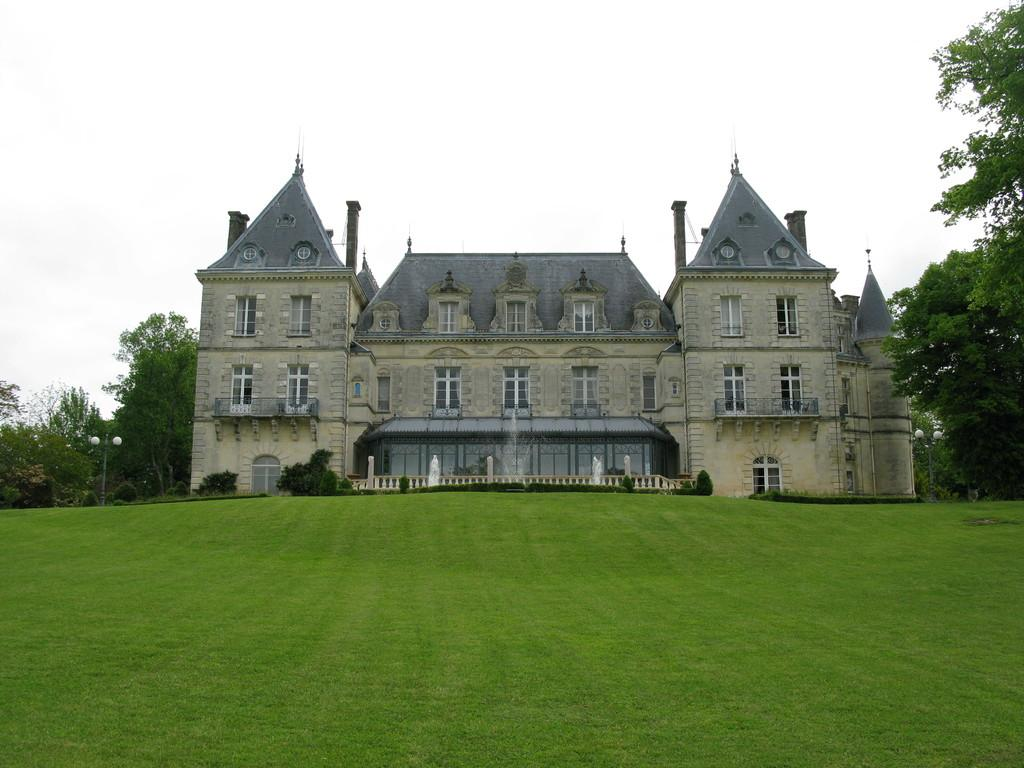What is the main structure in the center of the image? There is a building in the center of the image. What type of natural elements can be seen in the image? There are trees in the image. What are the vertical structures in the image? There are poles in the image. What type of water feature is present in the image? There is a fountain in the image. What can be seen in the background of the image? The sky is visible in the background of the image. How many chairs are placed around the fountain in the image? There are no chairs present in the image; it only features a building, trees, poles, a fountain, and the sky. 